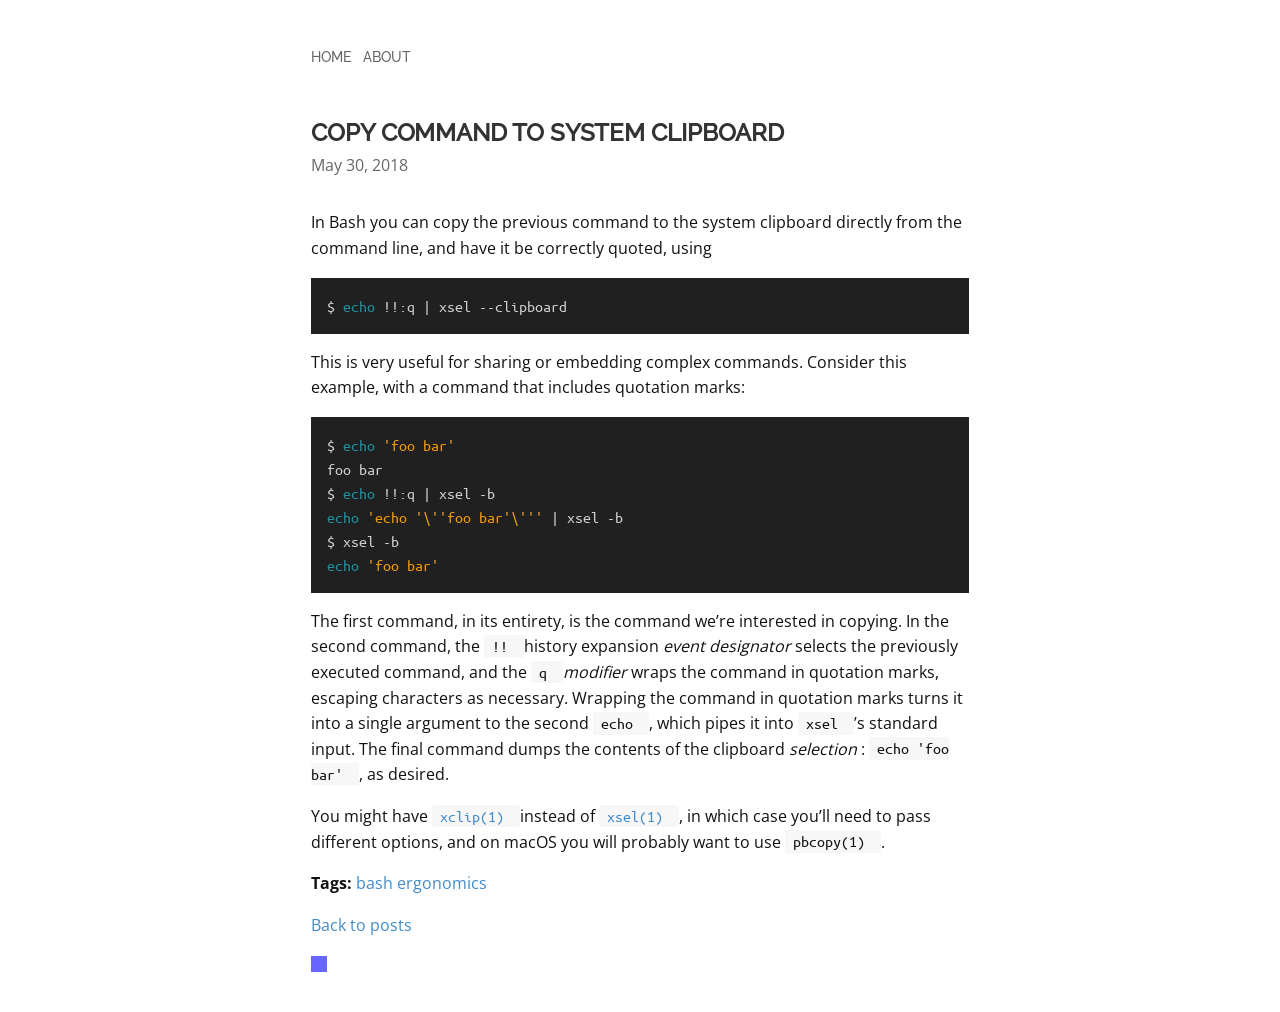How should I handle typography to ensure the text on the site is clear and professional like in the image? For clear and professional typography, choose a font similar to that in the image, which looks like a clean monospace style. Utilize CSS to set the 'font-family', adjusting 'font-size', 'line-height', and 'letter-spacing' to enhance readability. Consider the use of web fonts from services like Google Fonts to ensure high-quality rendering across all devices. Also, set 'color' to a dark hue on a lighter background for strong contrast, and use 'font-weight' to differentiate headings from body text effectively. 